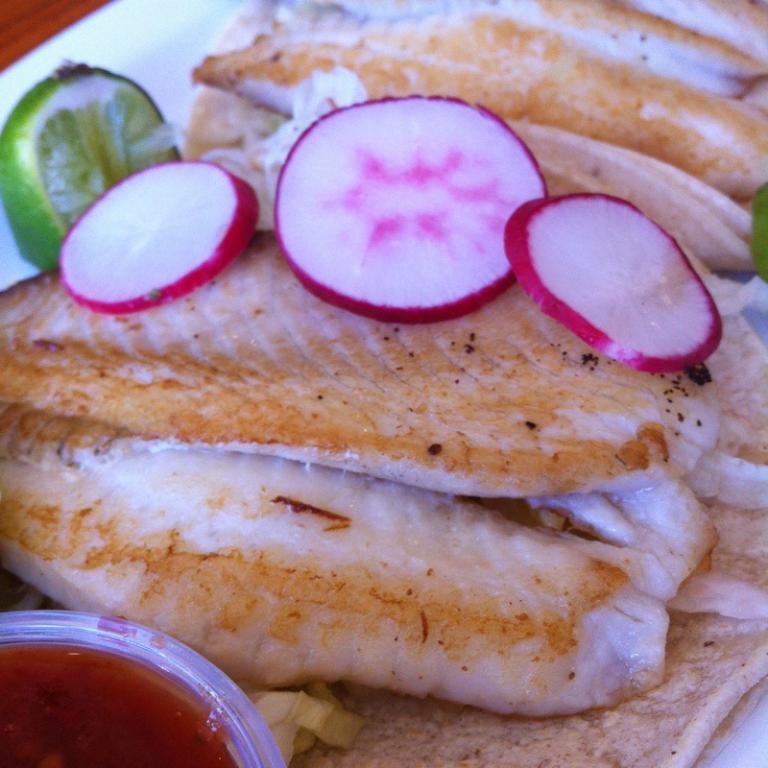Describe this image in one or two sentences. In this image I can see a plate which consists of meat and some other food items. At the bottom there is a bowl. 